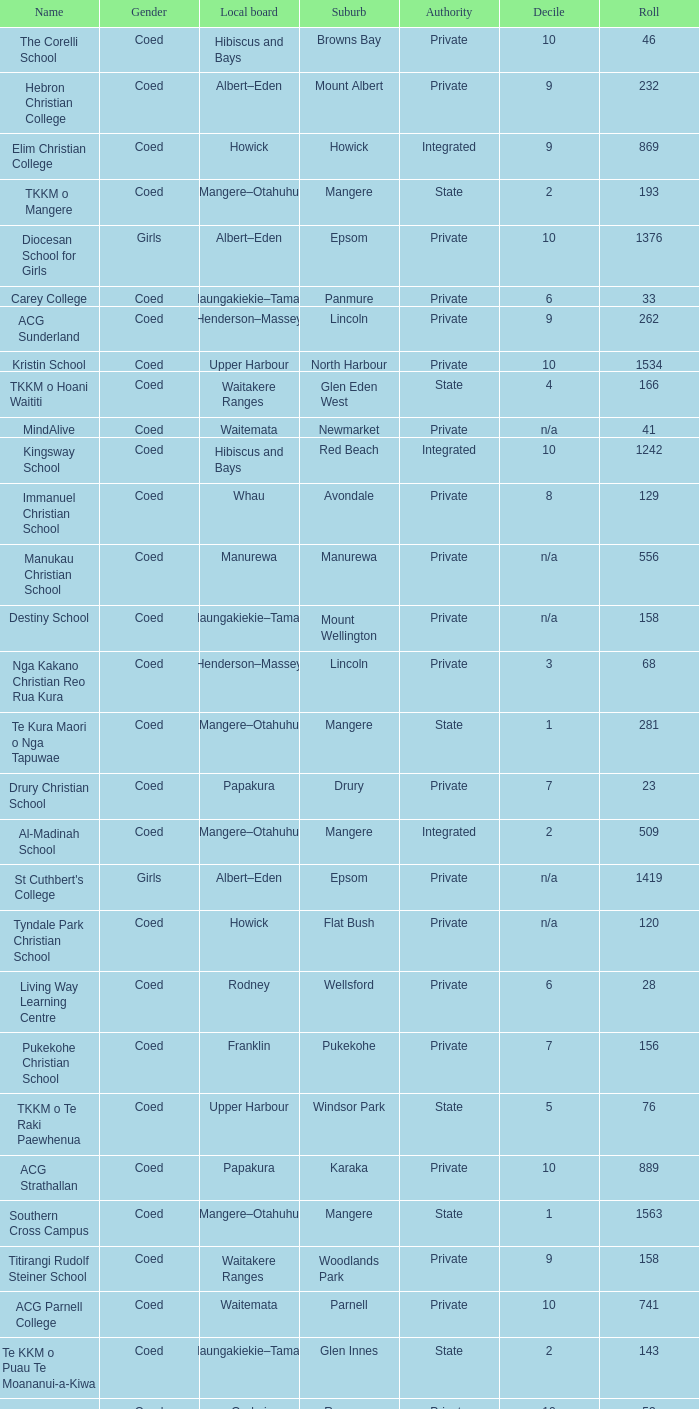What is the name of the suburb with a roll of 741? Parnell. 